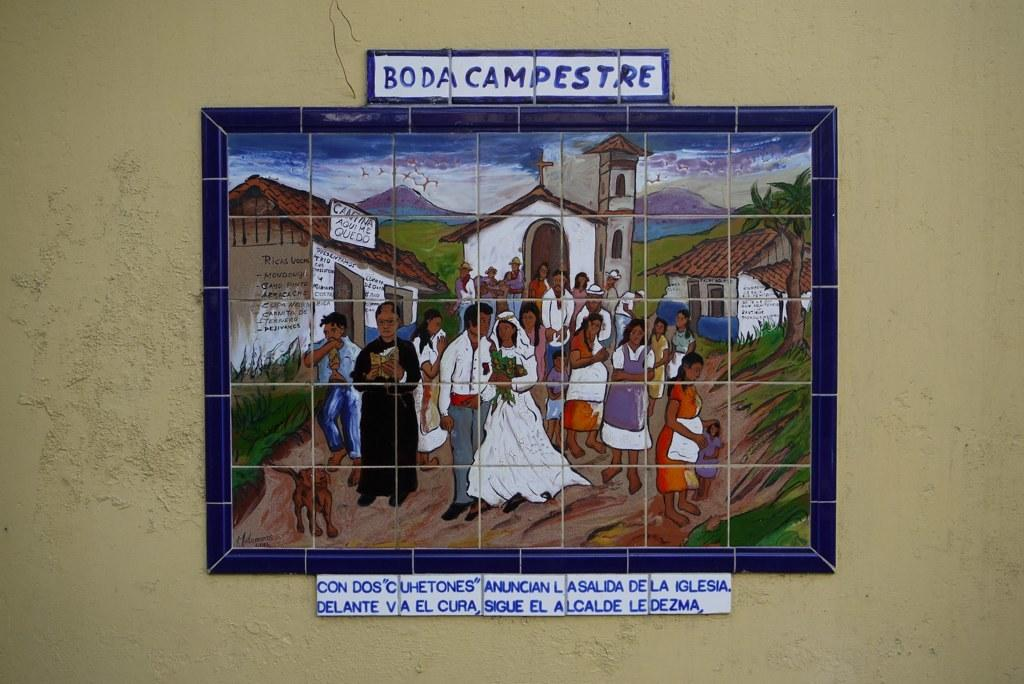Provide a one-sentence caption for the provided image. A painting made up of different tiles is titled "Boda Campestre". 